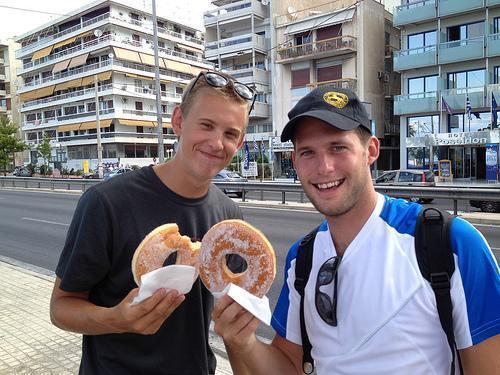How many donuts are there?
Give a very brief answer. 2. 